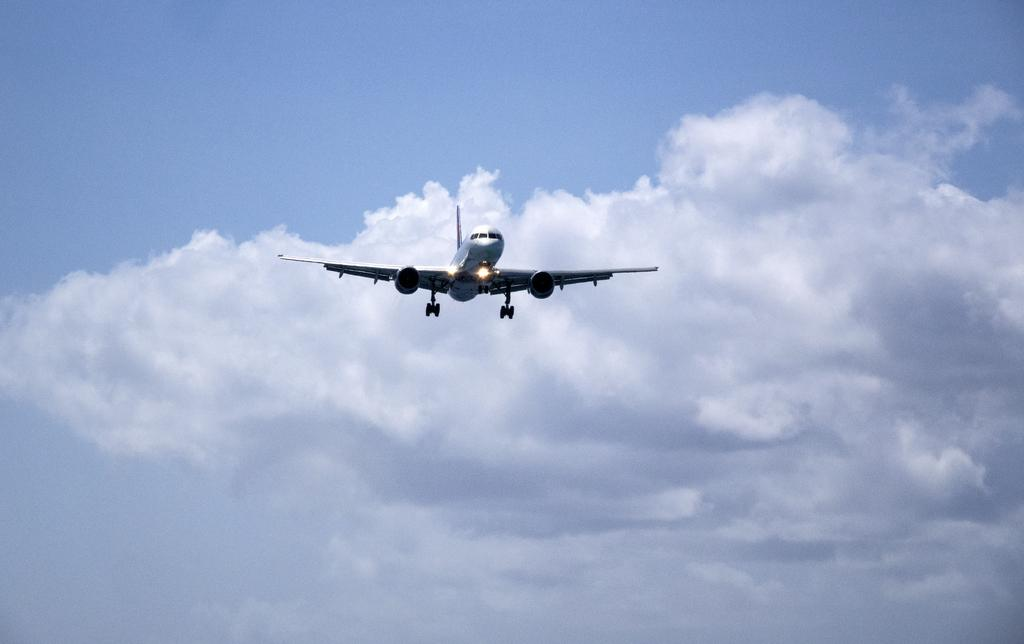What is the main subject of the image? The main subject of the image is an airplane. What color is the airplane? The airplane is white. What is the airplane doing in the image? The airplane is flying in the sky. What can be seen in the sky besides the airplane? There are clouds visible in the sky, and the sky is blue. Can you hear the ear of the beast in the image? There is no beast or ear present in the image; it features an airplane flying in the sky. 